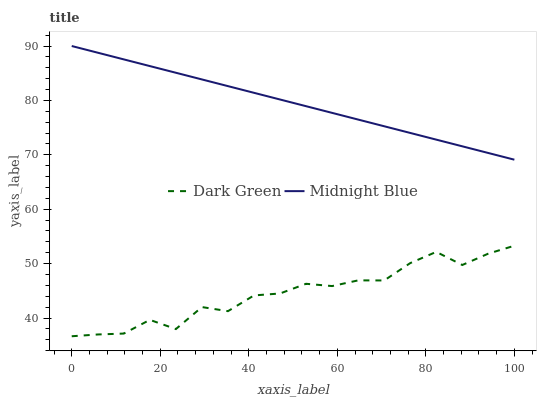Does Dark Green have the maximum area under the curve?
Answer yes or no. No. Is Dark Green the smoothest?
Answer yes or no. No. Does Dark Green have the highest value?
Answer yes or no. No. Is Dark Green less than Midnight Blue?
Answer yes or no. Yes. Is Midnight Blue greater than Dark Green?
Answer yes or no. Yes. Does Dark Green intersect Midnight Blue?
Answer yes or no. No. 